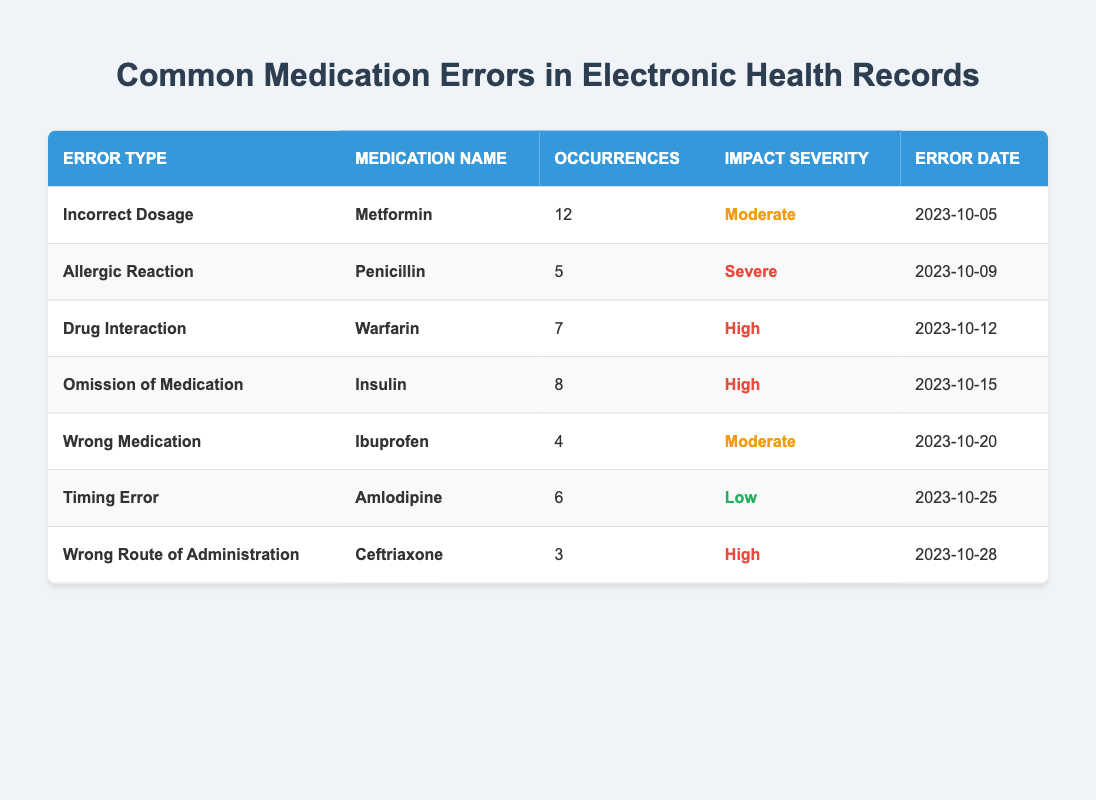What is the most common medication error recorded? The table shows the occurrences of each error type. The highest occurrence is **12** for **Incorrect Dosage** of **Metformin**.
Answer: Incorrect Dosage How many occurrences were recorded for **Penicillin**? The table indicates that **Penicillin** was involved in **5** occurrences of **Allergic Reaction**.
Answer: 5 Which medication has the highest severity impact? The errors with the highest severity are marked as **Severe** and **High**. The **Allergic Reaction** for **Penicillin** is rated **Severe**, while the **Drug Interaction** with **Warfarin**, and **Omission of Medication** with **Insulin** are rated **High**, making **Penicillin** the highest severity medication.
Answer: Penicillin How many total occurrences are there for medications with **High** impact severity? The medications with **High** impact are **Warfarin**, **Insulin**, and **Ceftriaxone** with occurrences of **7**, **8**, and **3** respectively. Summing these gives **7 + 8 + 3 = 18**.
Answer: 18 Which medication has the least occurrences of errors? Reviewing the table shows that **Ceftriaxone** has **3** occurrences of **Wrong Route of Administration**, which is the lowest number compared to the others listed.
Answer: Ceftriaxone Are there any errors related to **Amlodipine**? Yes, the table indicates there is a **Timing Error** related to **Amlodipine**, with **6** occurrences and is classified as **Low** impact severity.
Answer: Yes What is the total number of occurrences for errors with **Moderate** severity? The medications with **Moderate** severity are **Metformin** (12 occurrences) and **Ibuprofen** (4 occurrences). Adding them gives **12 + 4 = 16**.
Answer: 16 Which error type has the second most occurrences? The error type with the second most occurrences is **Omission of Medication** for **Insulin**, which has **8** occurrences, following **Incorrect Dosage**.
Answer: Omission of Medication Is there any medication error classified as **Low** severity? Yes, there is a **Timing Error** related to **Amlodipine** classified as **Low** severity, with **6** occurrences.
Answer: Yes What percentage of errors resulted from **Drug Interaction** compared to total occurrences? The total occurrences are **45** (12 + 5 + 7 + 8 + 4 + 6 + 3). The **Drug Interaction** accounts for **7** occurrences, so the percentage is (7/45) * 100 = **15.56%**.
Answer: 15.56% 